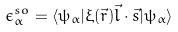Convert formula to latex. <formula><loc_0><loc_0><loc_500><loc_500>\epsilon _ { \alpha } ^ { s o } = \langle \psi _ { \alpha } | \xi ( \vec { r } ) \vec { l } \cdot \vec { s } | \psi _ { \alpha } \rangle</formula> 